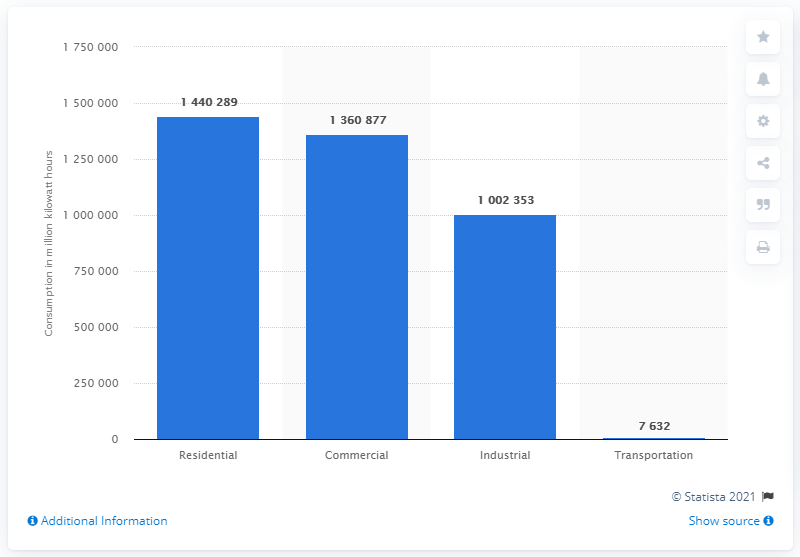Highlight a few significant elements in this photo. The transportation sector consumes approximately 7632 megawatt-hours of electricity per year. 